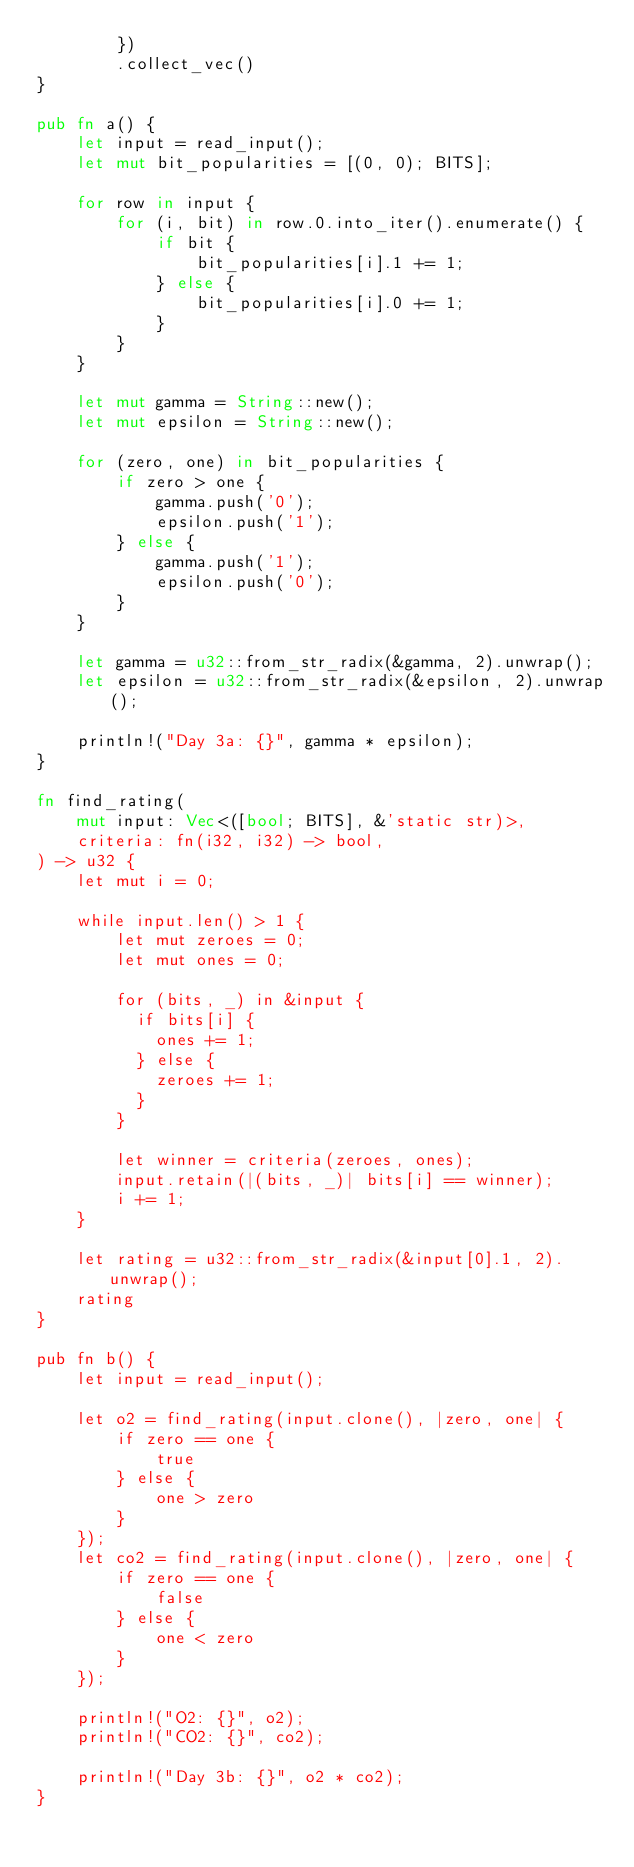<code> <loc_0><loc_0><loc_500><loc_500><_Rust_>        })
        .collect_vec()
}

pub fn a() {
    let input = read_input();
    let mut bit_popularities = [(0, 0); BITS];

    for row in input {
        for (i, bit) in row.0.into_iter().enumerate() {
            if bit {
                bit_popularities[i].1 += 1;
            } else {
                bit_popularities[i].0 += 1;
            }
        }
    }

    let mut gamma = String::new();
    let mut epsilon = String::new();

    for (zero, one) in bit_popularities {
        if zero > one {
            gamma.push('0');
            epsilon.push('1');
        } else {
            gamma.push('1');
            epsilon.push('0');
        }
    }

    let gamma = u32::from_str_radix(&gamma, 2).unwrap();
    let epsilon = u32::from_str_radix(&epsilon, 2).unwrap();

    println!("Day 3a: {}", gamma * epsilon);
}

fn find_rating(
    mut input: Vec<([bool; BITS], &'static str)>,
    criteria: fn(i32, i32) -> bool,
) -> u32 {
    let mut i = 0;

    while input.len() > 1 {
        let mut zeroes = 0;
        let mut ones = 0;

        for (bits, _) in &input {
          if bits[i] {
            ones += 1;
          } else {
            zeroes += 1;
          }
        }

        let winner = criteria(zeroes, ones);
        input.retain(|(bits, _)| bits[i] == winner);
        i += 1;
    }

    let rating = u32::from_str_radix(&input[0].1, 2).unwrap();
    rating
}

pub fn b() {
    let input = read_input();

    let o2 = find_rating(input.clone(), |zero, one| {
        if zero == one {
            true
        } else {
            one > zero
        }
    });
    let co2 = find_rating(input.clone(), |zero, one| {
        if zero == one {
            false
        } else {
            one < zero
        }
    });

    println!("O2: {}", o2);
    println!("CO2: {}", co2);

    println!("Day 3b: {}", o2 * co2);
}
</code> 